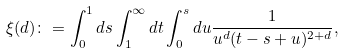Convert formula to latex. <formula><loc_0><loc_0><loc_500><loc_500>\xi ( d ) \colon = \int _ { 0 } ^ { 1 } d s \int _ { 1 } ^ { \infty } d t \int _ { 0 } ^ { s } d u \frac { 1 } { u ^ { d } ( t - s + u ) ^ { 2 + d } } ,</formula> 